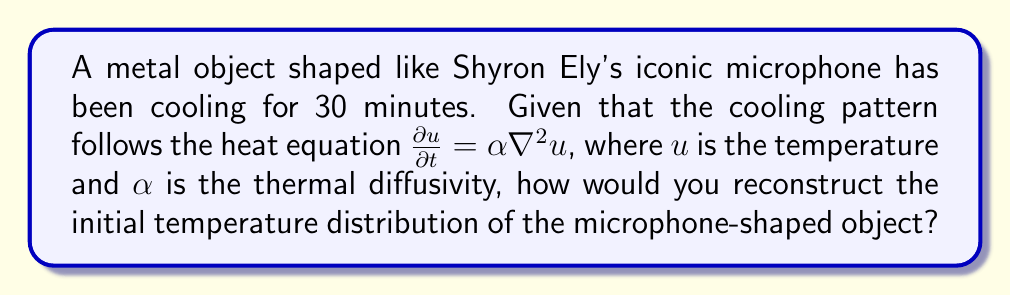What is the answer to this math problem? To reconstruct the initial temperature distribution of the microphone-shaped object, we need to solve an inverse problem using the heat equation. Here's a step-by-step approach:

1. Formulate the forward problem:
   The heat equation in 3D is given by:
   $$\frac{\partial u}{\partial t} = \alpha \left(\frac{\partial^2 u}{\partial x^2} + \frac{\partial^2 u}{\partial y^2} + \frac{\partial^2 u}{\partial z^2}\right)$$

2. Define boundary conditions:
   We need to specify the temperature at the surface of the microphone-shaped object.

3. Collect measurement data:
   Obtain temperature measurements at various points on the object's surface after 30 minutes of cooling.

4. Choose a regularization method:
   Due to the ill-posedness of inverse heat conduction problems, we need to use regularization. Tikhonov regularization is a common choice:
   $$\min_{u_0} \|Au_0 - b\|^2 + \lambda \|Lu_0\|^2$$
   where $A$ is the forward operator, $u_0$ is the initial temperature distribution, $b$ is the measured data, $\lambda$ is the regularization parameter, and $L$ is a regularization operator.

5. Discretize the problem:
   Use finite differences or finite elements to discretize the spatial and temporal domains.

6. Implement an iterative algorithm:
   Use methods like conjugate gradient or LSQR to solve the regularized minimization problem.

7. Validate the solution:
   Compare the reconstructed initial temperature distribution with the measured cooling pattern by solving the forward problem.

8. Refine the reconstruction:
   Adjust the regularization parameter and repeat steps 6-7 until a satisfactory reconstruction is obtained.

The final reconstructed initial temperature distribution will provide an estimate of how the microphone-shaped object's temperature was distributed at the beginning of the cooling process.
Answer: Solve inverse heat equation using regularization and iterative optimization 